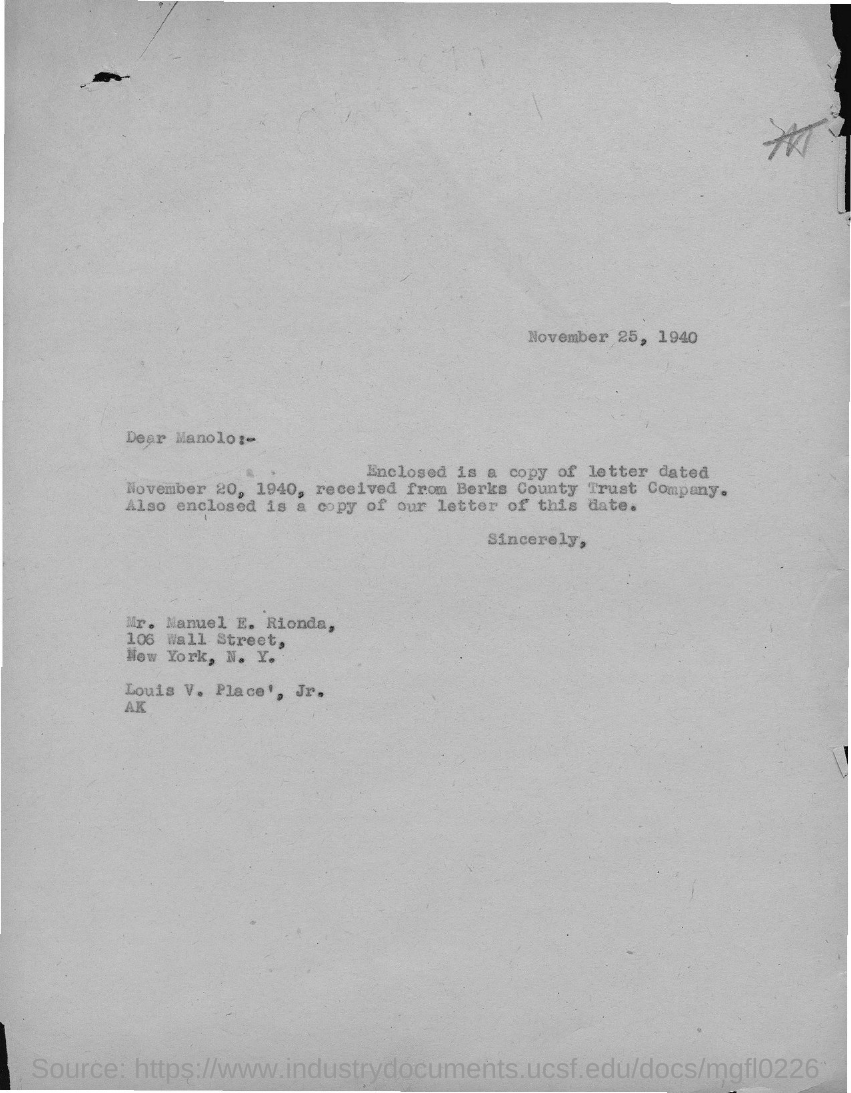What is the date on the document?
Make the answer very short. November 25, 1940. To Whom is this letter addressed to?
Provide a short and direct response. Manolo. 